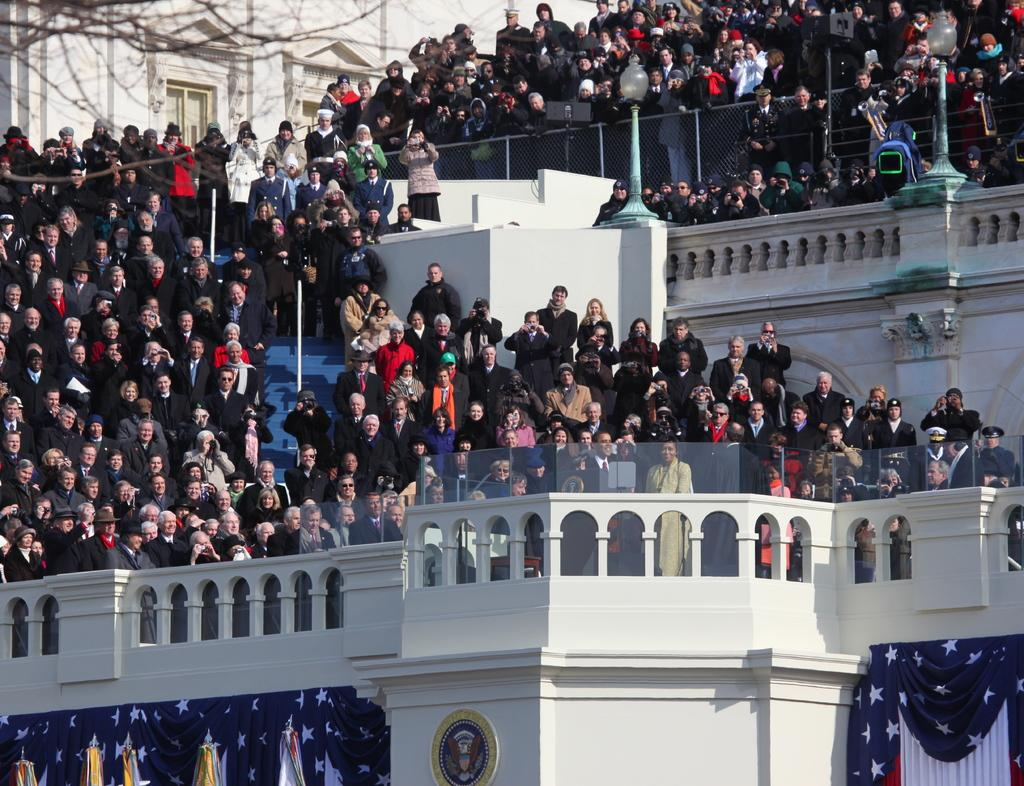How many people are in the image? There is a group of people in the image, but the exact number is not specified. What type of structure can be seen in the image? There is a building in the image. What is the purpose of the fence in the image? The purpose of the fence in the image is not specified. What type of plant is present in the image? There is a tree in the image. What are the poles in the image used for? The purpose of the poles in the image is not specified. What do the flags in the image represent? The flags in the image may represent a country, organization, or event, but their specific meaning is not specified. Can you describe the unspecified objects in the image? The unspecified objects in the image cannot be described as their nature is not mentioned in the provided facts. How does the group of people increase their productivity in the image? There is no information about the productivity of the group of people in the image. What type of geese are present in the image? There are no geese present in the image. What type of business is being conducted in the image? There is no information about a business being conducted in the image. 